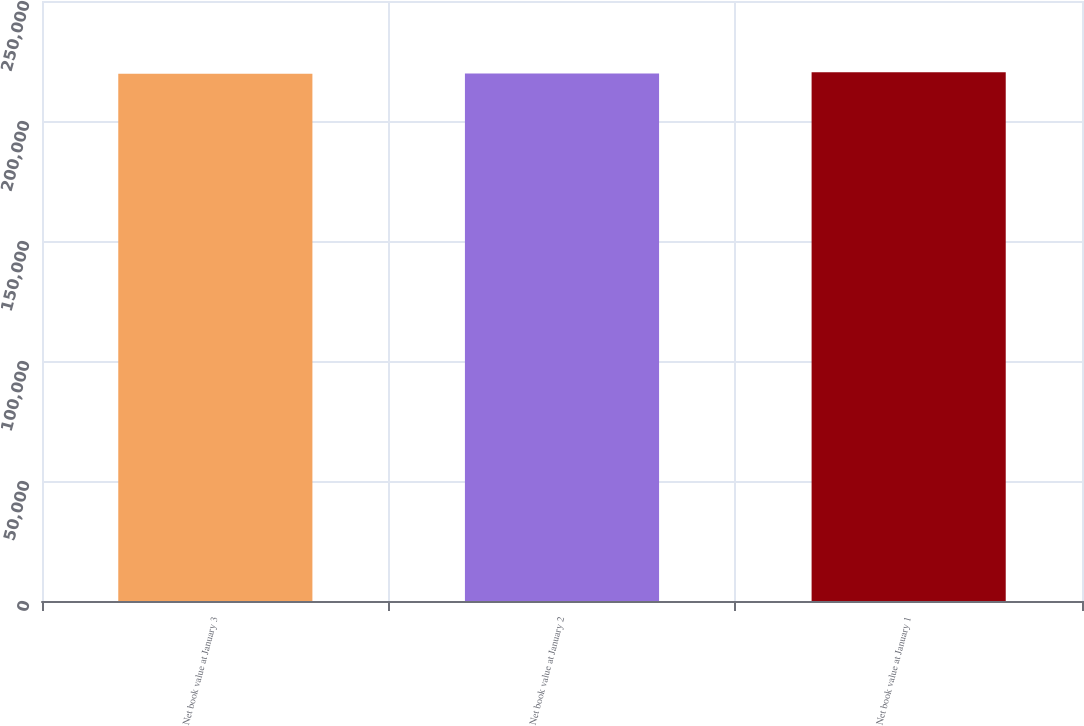<chart> <loc_0><loc_0><loc_500><loc_500><bar_chart><fcel>Net book value at January 3<fcel>Net book value at January 2<fcel>Net book value at January 1<nl><fcel>219729<fcel>219789<fcel>220332<nl></chart> 